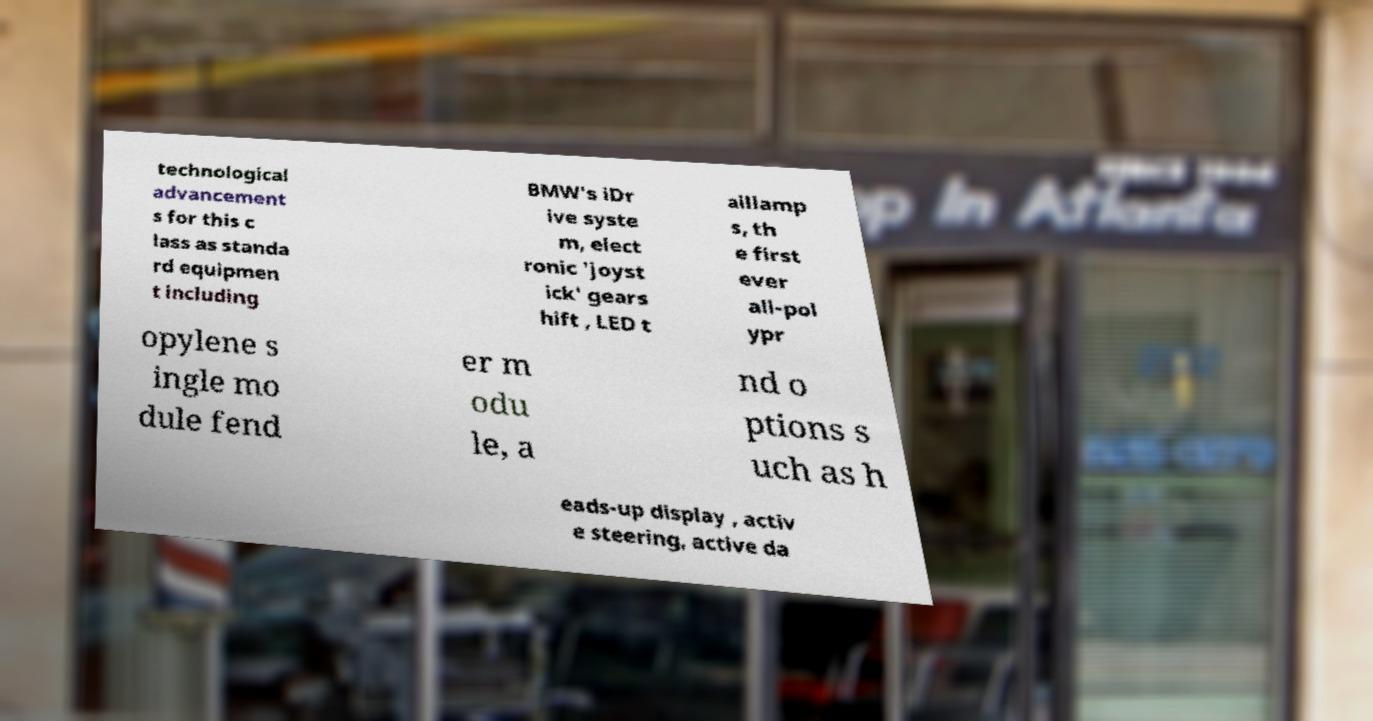Please identify and transcribe the text found in this image. technological advancement s for this c lass as standa rd equipmen t including BMW's iDr ive syste m, elect ronic 'joyst ick' gears hift , LED t aillamp s, th e first ever all-pol ypr opylene s ingle mo dule fend er m odu le, a nd o ptions s uch as h eads-up display , activ e steering, active da 